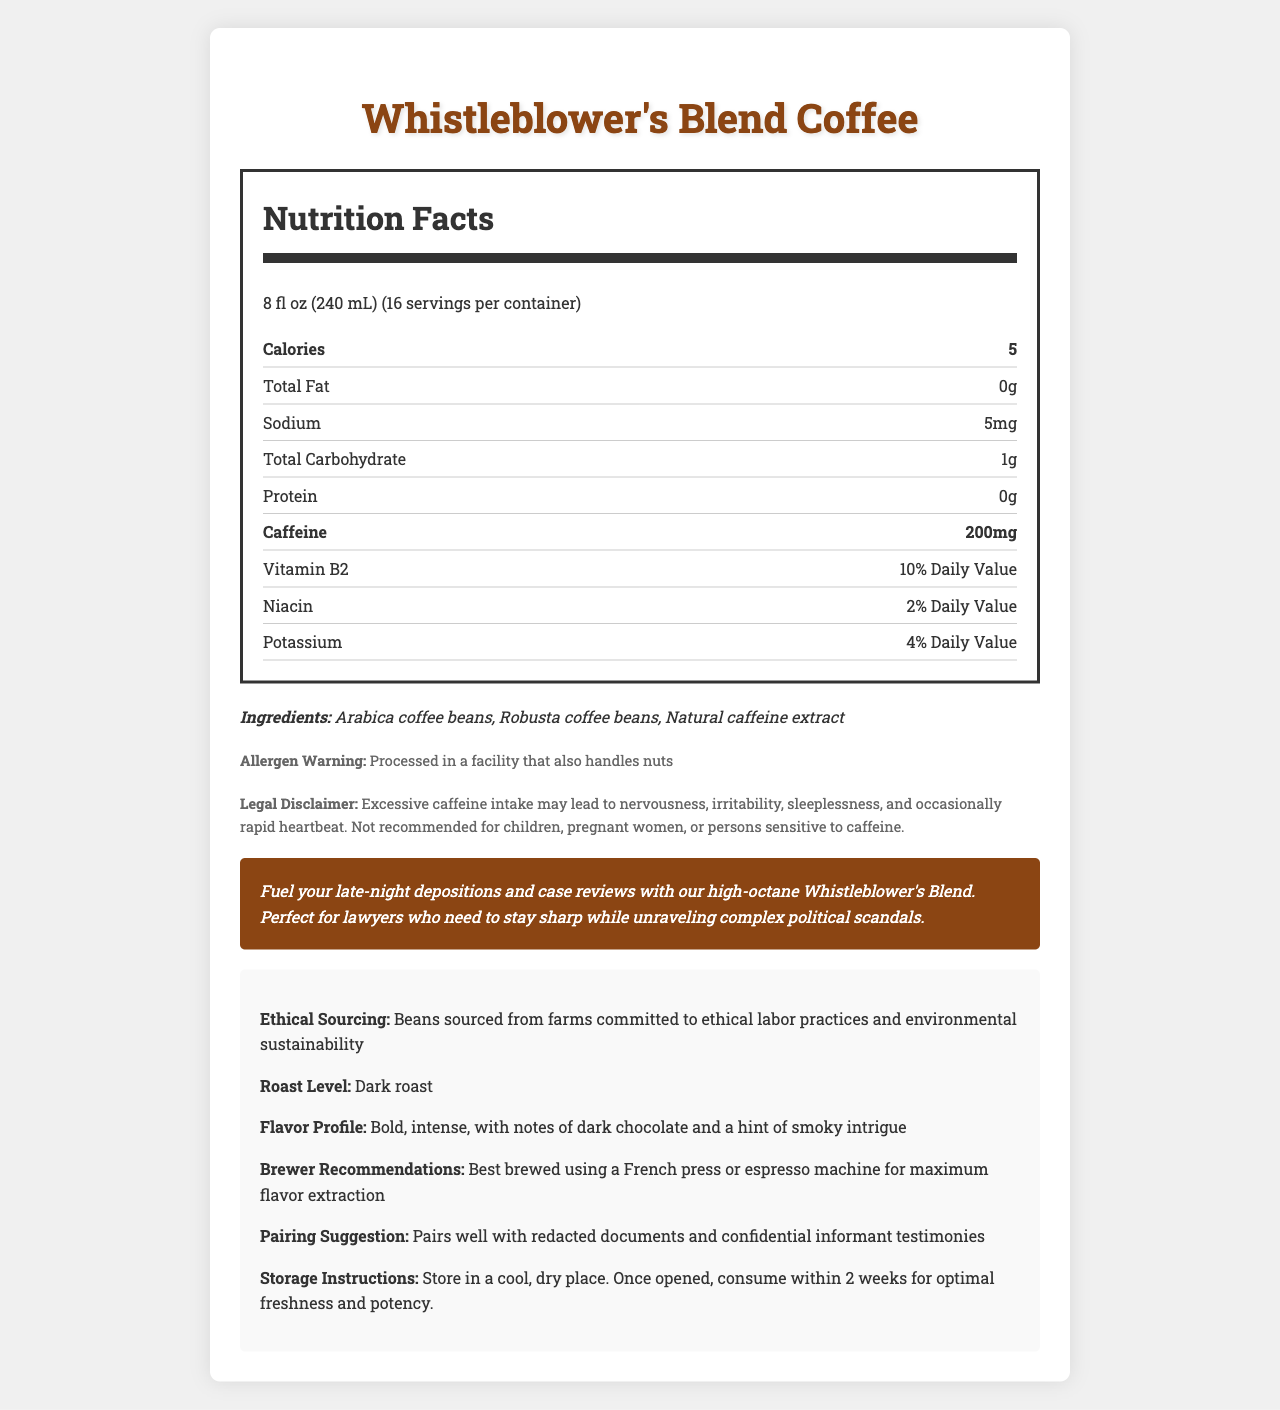what is the caffeine content per serving? The document shows that each serving of Whistleblower's Blend Coffee contains 200mg of caffeine.
Answer: 200mg For whom is the coffee not recommended according to the legal disclaimer? The legal disclaimer in the document specifies that the coffee is not recommended for children, pregnant women, or persons sensitive to caffeine.
Answer: Children, pregnant women, or persons sensitive to caffeine what is the serving size of Whistleblower's Blend coffee? The serving size provided in the document is 8 fl oz (240 mL).
Answer: 8 fl oz (240 mL) How many servings are there in a container of Whistleblower's Blend coffee? The document indicates that there are 16 servings per container.
Answer: 16 Which vitamins and minerals does Whistleblower's Blend coffee provide? According to the document, the coffee provides Vitamin B2 (10% Daily Value), Niacin (2% Daily Value), and Potassium (4% Daily Value).
Answer: Vitamin B2, Niacin, Potassium what are the ingredients of Whistleblower's Blend coffee? The document lists the ingredients as Arabica coffee beans, Robusta coffee beans, and natural caffeine extract.
Answer: Arabica coffee beans, Robusta coffee beans, Natural caffeine extract What is the total carbohydrate content per serving? A. 0g B. 1g C. 5g D. 10g The document shows that each serving contains 1g of total carbohydrates.
Answer: B. 1g What is the flavor profile of Whistleblower's Blend coffee? A. Mild and fruity B. Sweet and floral C. Bold and intense D. Light and nutty The flavor profile described in the document is bold and intense, with notes of dark chocolate and a hint of smoky intrigue.
Answer: C. Bold and intense Is this product considered high in caffeine? (yes/no) The document indicates that the product has a high caffeine content of 200mg per serving.
Answer: Yes Summarize the Nutrition Facts label for Whistleblower's Blend coffee. This summary covers all major aspects: product details, nutritional information, ingredients, warnings, and brand-specific marketing statements.
Answer: Whistleblower's Blend coffee offers a high-caffeine content at 200mg per serving in an 8 fl oz (240 mL) size. Each container provides 16 servings. The coffee is low in calories (5 kcal), total fat (0g), and protein (0g), and includes small amounts of sodium (5mg), total carbohydrate (1g), Vitamin B2 (10% Daily Value), Niacin (2% Daily Value), and Potassium (4% Daily Value). Ingredients include Arabica coffee beans, Robusta coffee beans, and natural caffeine extract. The product has an allergen warning and a legal disclaimer regarding excessive caffeine intake. It is marketed for lawyers needing to stay alert with ethical sourcing practices, a dark roast level, and bold flavor profile. What is the recommended brewing method for this coffee? The document recommends brewing Whistleblower's Blend coffee using a French press or espresso machine for maximum flavor extraction.
Answer: French press or espresso machine How does the brand market Whistleblower's Blend? The brand statement in the document markets the coffee as a high-octane option perfect for lawyers who need to stay sharp while unraveling complex political scandals.
Answer: As a high-octane coffee perfect for lawyers who need to stay alert while dealing with political scandals. What is the total fat content in one serving? The document indicates that the total fat content per serving of Whistleblower's Blend coffee is 0g.
Answer: 0g How long should the coffee be consumed after opening for optimal freshness and potency? The storage instructions specify that the coffee should be consumed within 2 weeks of opening for optimal freshness and potency.
Answer: Within 2 weeks What is the percentage of the daily value of potassium in a serving? The document lists the potassium content as 4% of the daily value.
Answer: 4% Daily Value What is the legal disclaimer regarding excessive caffeine intake? The legal disclaimer in the document details the potential effects of excessive caffeine intake and specifies who should avoid it.
Answer: Excessive caffeine intake may lead to nervousness, irritability, sleeplessness, and occasionally rapid heartbeat. Not recommended for children, pregnant women, or persons sensitive to caffeine. Does the document provide information about the source of the coffee beans? (yes/no) The document indicates that the beans are sourced from farms committed to ethical labor practices and environmental sustainability.
Answer: Yes Is there a specific allergen warning mentioned? The document includes an allergen warning that the product is processed in a facility that also handles nuts.
Answer: Yes What are the ethical practices mentioned in the document? The document states that the coffee beans are sourced from farms committed to ethical labor practices and environmental sustainability.
Answer: Ethical labor practices and environmental sustainability What is the legal status of the employees at the farms where the beans are sourced? The document mentions ethical labor practices but does not provide specific details about the legal status of the employees at the farms.
Answer: Cannot be determined 